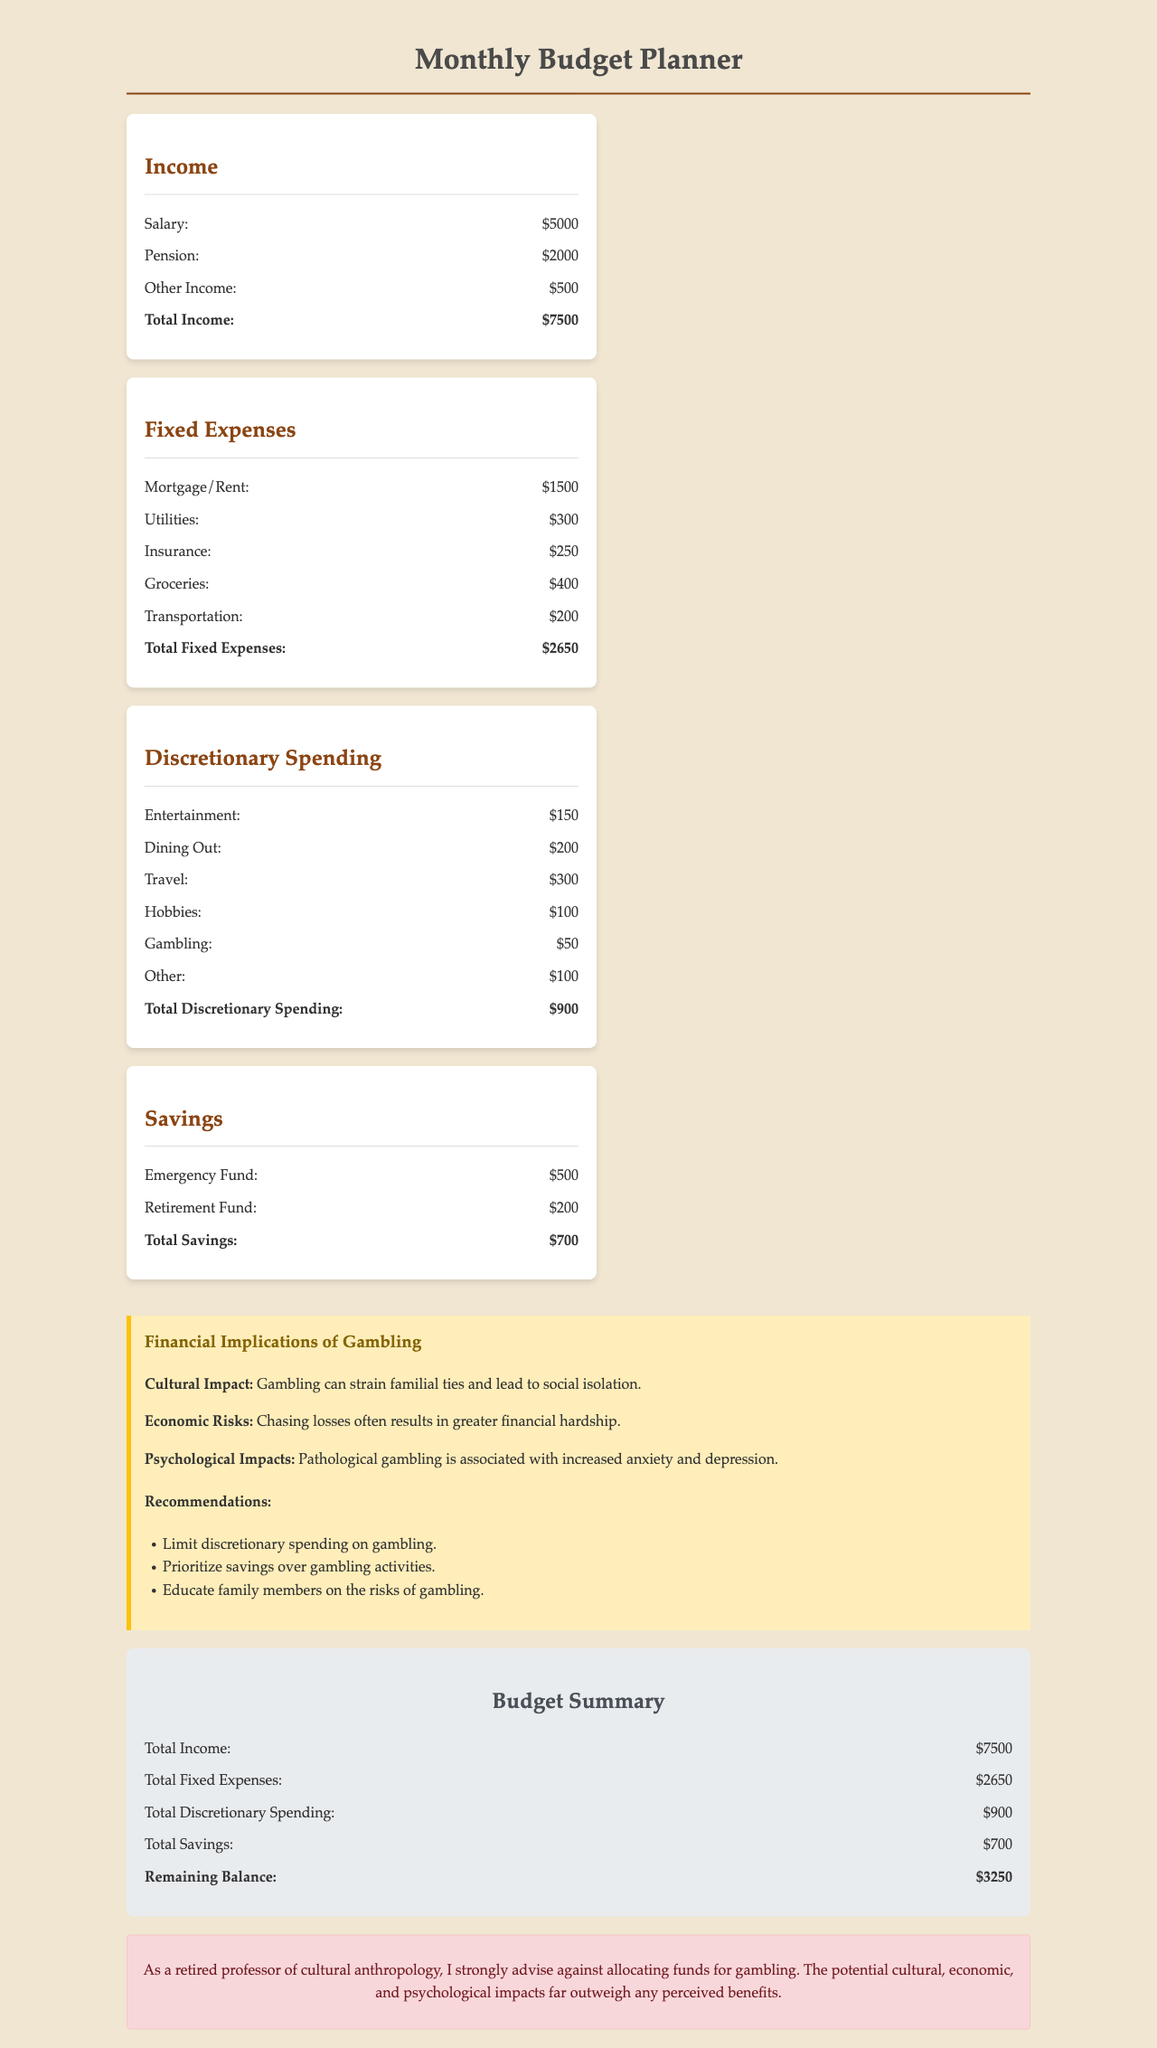what is the total income? The total income is the sum of all income sources in the document, which is $5000 + $2000 + $500 = $7500.
Answer: $7500 how much is allocated for gambling? The gambling budget is specifically listed in the discretionary spending section of the document, which shows $50.
Answer: $50 what are the total fixed expenses? The total fixed expenses are calculated by summing all fixed costs in the document, totaling $1500 + $300 + $250 + $400 + $200 = $2650.
Answer: $2650 what is the remaining balance after expenses and savings? The remaining balance is the difference between total income and the sum of total fixed expenses and total savings, calculated as $7500 - ($2650 + $700) = $3250.
Answer: $3250 what is the recommendation regarding gambling? The document recommends limiting discretionary spending on gambling, emphasizing the importance of this financial choice.
Answer: Limit discretionary spending on gambling how much is budgeted for entertainment? The entertainment budget within discretionary spending is specifically noted in the document as $150.
Answer: $150 what is the total savings amount? The total savings is calculated by adding both savings categories listed in the document, which totals $500 + $200 = $700.
Answer: $700 what cultural impact does gambling have? The document mentions that gambling can strain familial ties and lead to social isolation.
Answer: Strain familial ties and lead to social isolation what is the purpose of the warning section? The warning section serves to advise against allocating funds for gambling and highlight potential negative impacts.
Answer: Advise against allocating funds for gambling what percentage of total income is spent on discretionary spending? The percent is calculated by dividing total discretionary spending by total income, giving $900 / $7500 * 100, equaling 12%.
Answer: 12% 